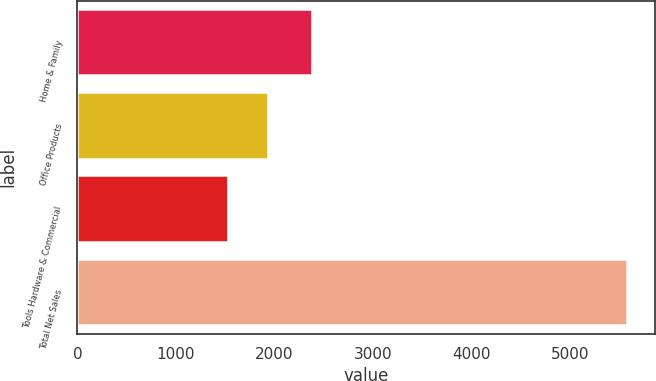Convert chart. <chart><loc_0><loc_0><loc_500><loc_500><bar_chart><fcel>Home & Family<fcel>Office Products<fcel>Tools Hardware & Commercial<fcel>Total Net Sales<nl><fcel>2377.2<fcel>1930.89<fcel>1525.7<fcel>5577.6<nl></chart> 